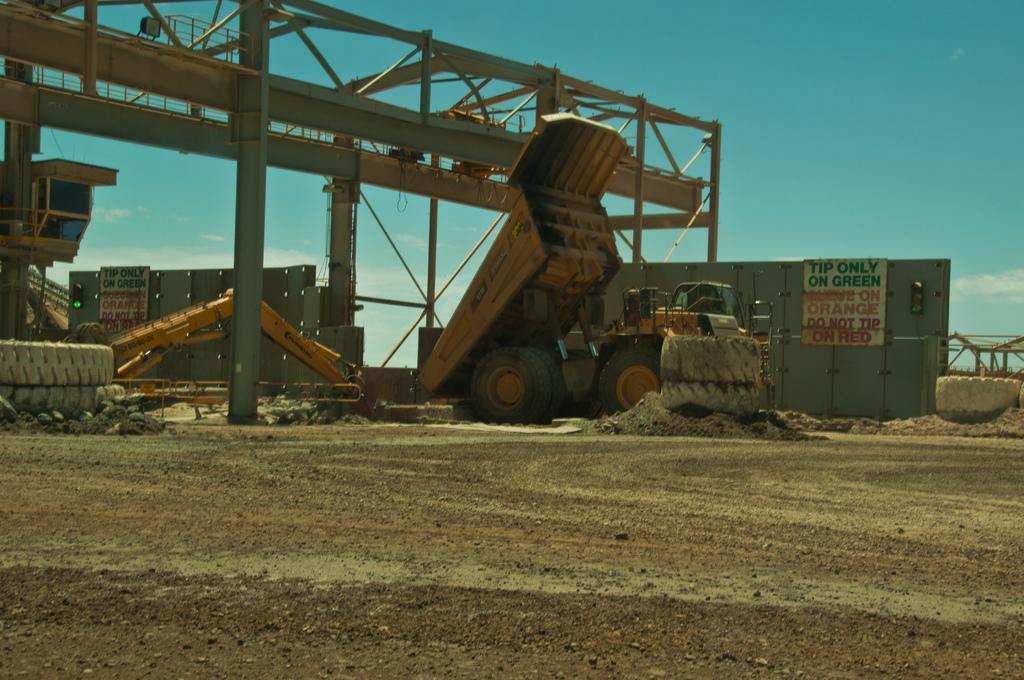Please provide a concise description of this image. In the center of the image there is a vehicle on the ground. On the left side of the image there is an equipment, tyres. On the right side of the image we can see tyres and wall. At the top there is a machinery. At the bottom we can see road. In the background there is a sky. 